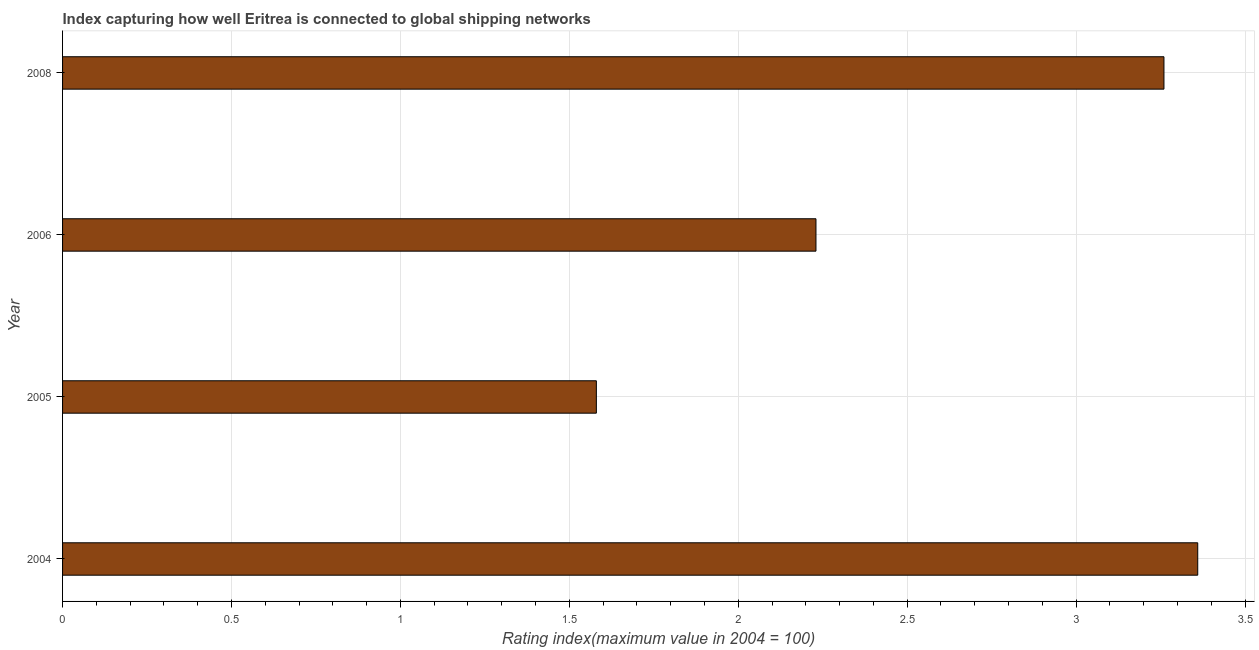Does the graph contain any zero values?
Your answer should be compact. No. Does the graph contain grids?
Provide a short and direct response. Yes. What is the title of the graph?
Provide a short and direct response. Index capturing how well Eritrea is connected to global shipping networks. What is the label or title of the X-axis?
Offer a terse response. Rating index(maximum value in 2004 = 100). What is the liner shipping connectivity index in 2005?
Provide a short and direct response. 1.58. Across all years, what is the maximum liner shipping connectivity index?
Your answer should be compact. 3.36. Across all years, what is the minimum liner shipping connectivity index?
Make the answer very short. 1.58. What is the sum of the liner shipping connectivity index?
Offer a very short reply. 10.43. What is the difference between the liner shipping connectivity index in 2005 and 2006?
Your answer should be compact. -0.65. What is the average liner shipping connectivity index per year?
Your answer should be compact. 2.61. What is the median liner shipping connectivity index?
Your response must be concise. 2.75. In how many years, is the liner shipping connectivity index greater than 3.2 ?
Provide a succinct answer. 2. What is the ratio of the liner shipping connectivity index in 2004 to that in 2006?
Keep it short and to the point. 1.51. Is the liner shipping connectivity index in 2004 less than that in 2006?
Your answer should be very brief. No. What is the difference between the highest and the lowest liner shipping connectivity index?
Your answer should be very brief. 1.78. How many bars are there?
Provide a short and direct response. 4. How many years are there in the graph?
Provide a succinct answer. 4. What is the difference between two consecutive major ticks on the X-axis?
Provide a short and direct response. 0.5. What is the Rating index(maximum value in 2004 = 100) in 2004?
Your answer should be compact. 3.36. What is the Rating index(maximum value in 2004 = 100) of 2005?
Ensure brevity in your answer.  1.58. What is the Rating index(maximum value in 2004 = 100) in 2006?
Ensure brevity in your answer.  2.23. What is the Rating index(maximum value in 2004 = 100) in 2008?
Provide a succinct answer. 3.26. What is the difference between the Rating index(maximum value in 2004 = 100) in 2004 and 2005?
Your answer should be very brief. 1.78. What is the difference between the Rating index(maximum value in 2004 = 100) in 2004 and 2006?
Give a very brief answer. 1.13. What is the difference between the Rating index(maximum value in 2004 = 100) in 2005 and 2006?
Provide a short and direct response. -0.65. What is the difference between the Rating index(maximum value in 2004 = 100) in 2005 and 2008?
Keep it short and to the point. -1.68. What is the difference between the Rating index(maximum value in 2004 = 100) in 2006 and 2008?
Your response must be concise. -1.03. What is the ratio of the Rating index(maximum value in 2004 = 100) in 2004 to that in 2005?
Give a very brief answer. 2.13. What is the ratio of the Rating index(maximum value in 2004 = 100) in 2004 to that in 2006?
Your answer should be very brief. 1.51. What is the ratio of the Rating index(maximum value in 2004 = 100) in 2004 to that in 2008?
Provide a succinct answer. 1.03. What is the ratio of the Rating index(maximum value in 2004 = 100) in 2005 to that in 2006?
Provide a short and direct response. 0.71. What is the ratio of the Rating index(maximum value in 2004 = 100) in 2005 to that in 2008?
Your response must be concise. 0.48. What is the ratio of the Rating index(maximum value in 2004 = 100) in 2006 to that in 2008?
Give a very brief answer. 0.68. 